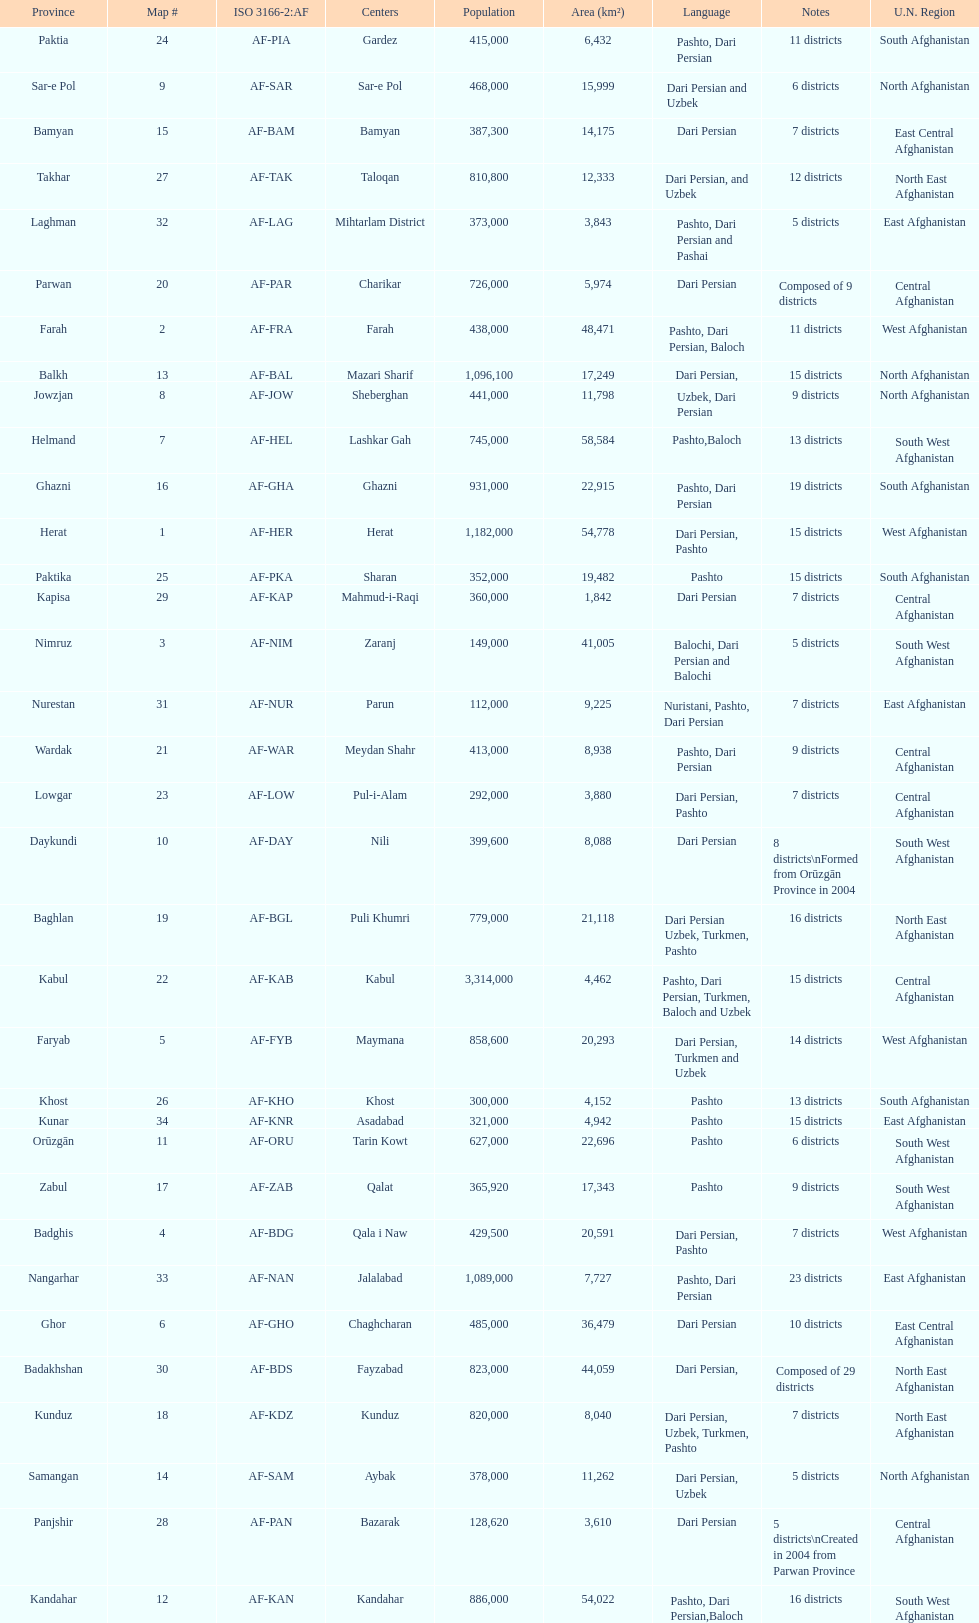What province is listed previous to ghor? Ghazni. 